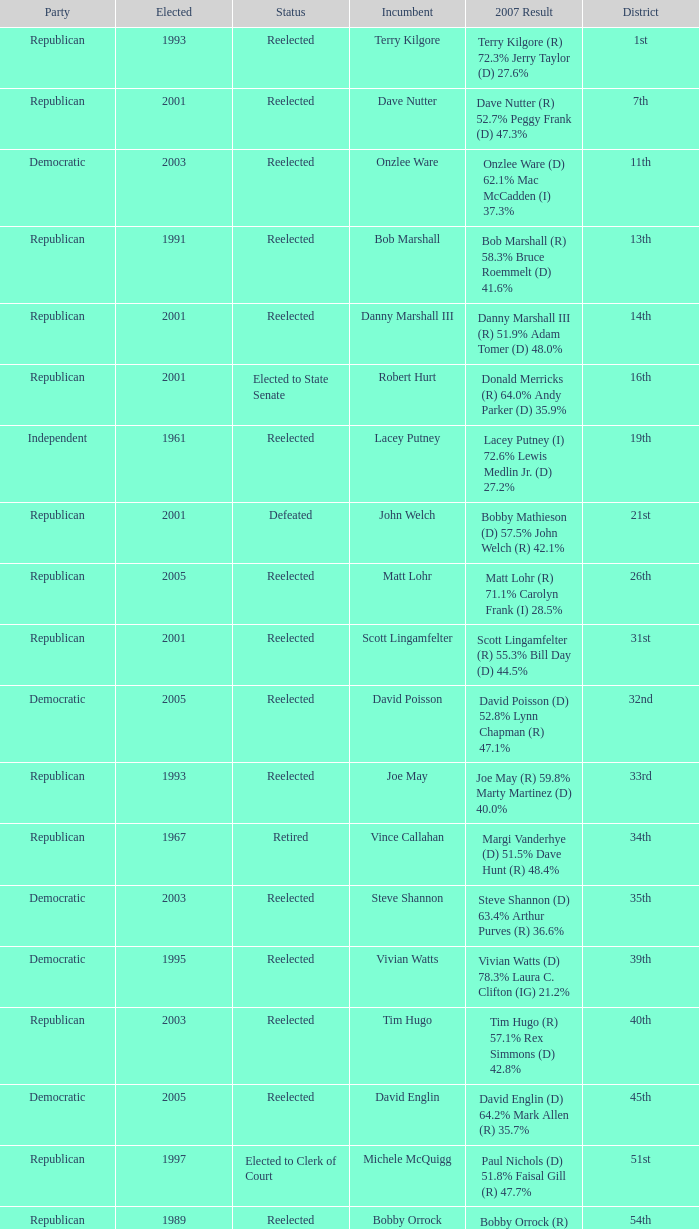How many election results are there from the 19th district? 1.0. 